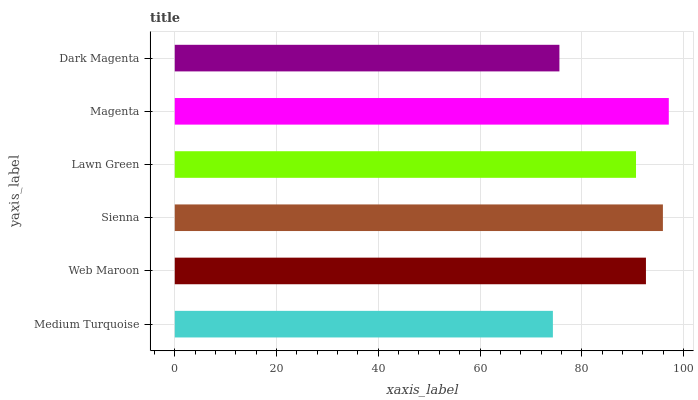Is Medium Turquoise the minimum?
Answer yes or no. Yes. Is Magenta the maximum?
Answer yes or no. Yes. Is Web Maroon the minimum?
Answer yes or no. No. Is Web Maroon the maximum?
Answer yes or no. No. Is Web Maroon greater than Medium Turquoise?
Answer yes or no. Yes. Is Medium Turquoise less than Web Maroon?
Answer yes or no. Yes. Is Medium Turquoise greater than Web Maroon?
Answer yes or no. No. Is Web Maroon less than Medium Turquoise?
Answer yes or no. No. Is Web Maroon the high median?
Answer yes or no. Yes. Is Lawn Green the low median?
Answer yes or no. Yes. Is Sienna the high median?
Answer yes or no. No. Is Dark Magenta the low median?
Answer yes or no. No. 